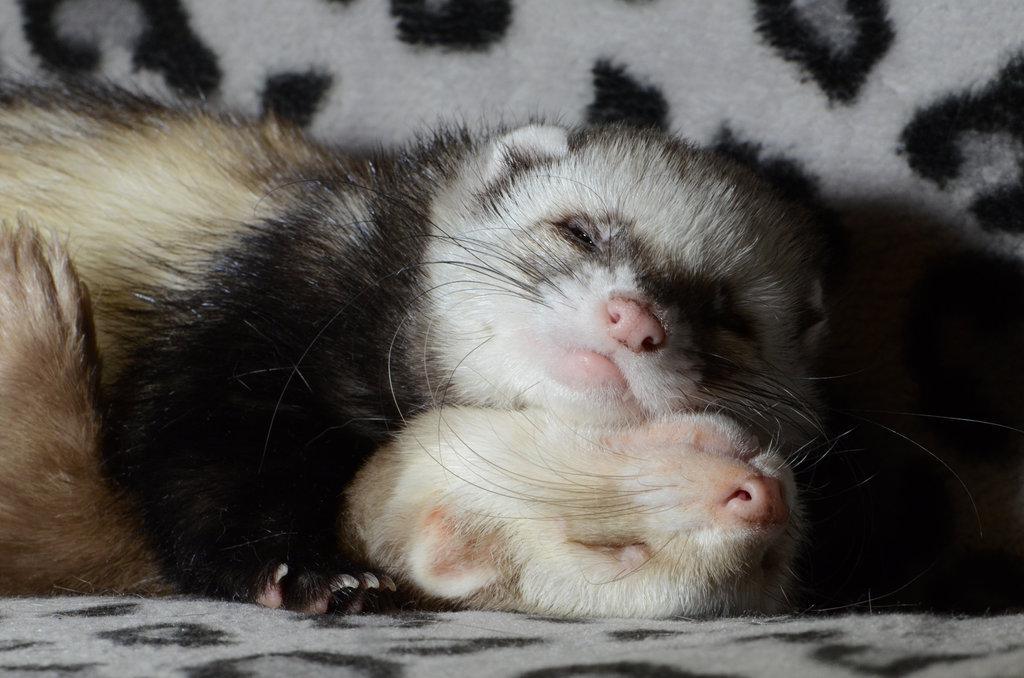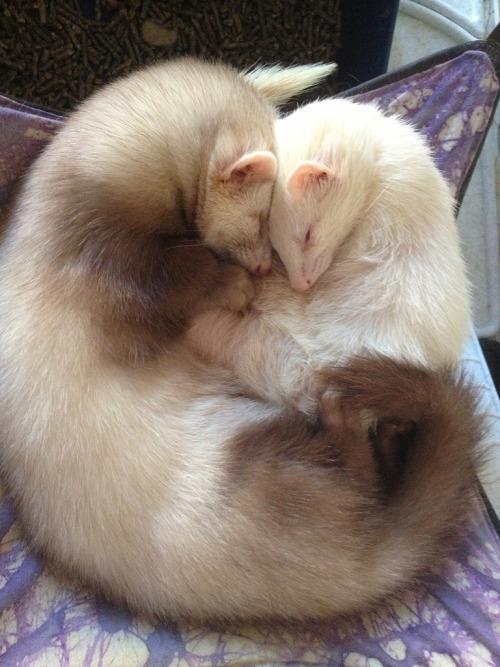The first image is the image on the left, the second image is the image on the right. Evaluate the accuracy of this statement regarding the images: "An image shows two ferrets snuggling to form a ball shape face-to-face.". Is it true? Answer yes or no. Yes. 